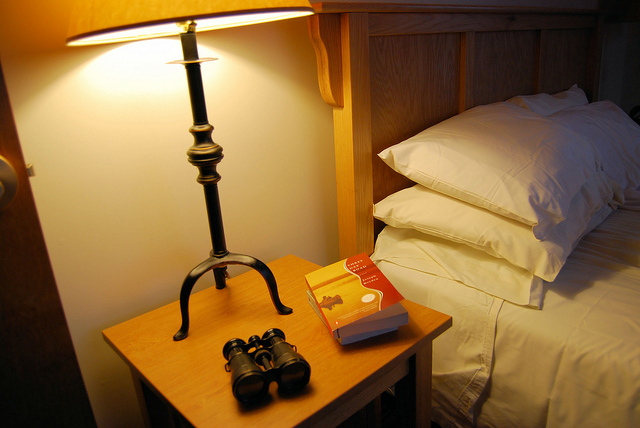How many pillows are there? 3 